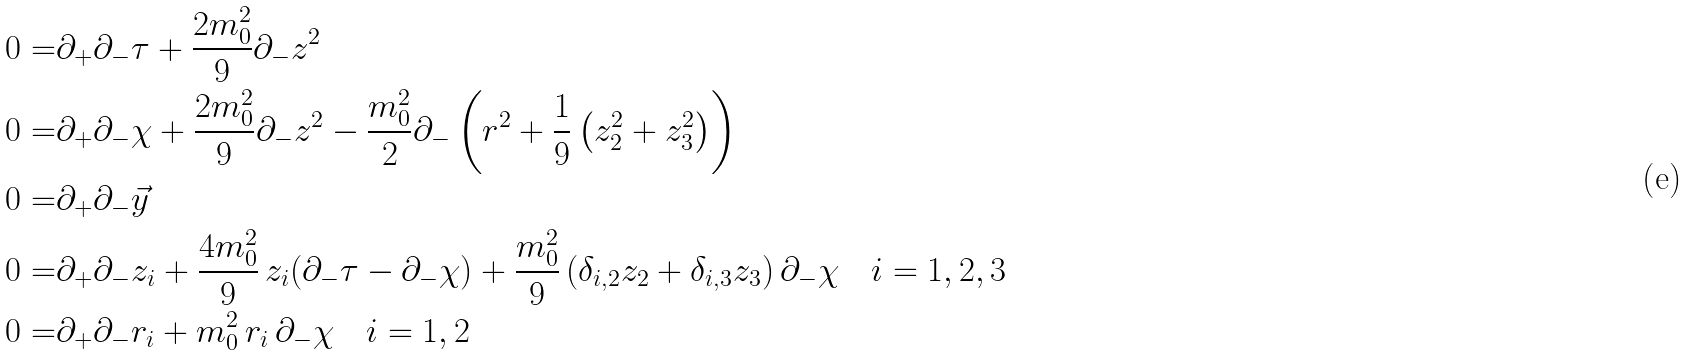<formula> <loc_0><loc_0><loc_500><loc_500>0 = & \partial _ { + } \partial _ { - } \tau + \frac { 2 m _ { 0 } ^ { 2 } } { 9 } \partial _ { - } z ^ { 2 } \\ 0 = & \partial _ { + } \partial _ { - } \chi + \frac { 2 m _ { 0 } ^ { 2 } } { 9 } \partial _ { - } z ^ { 2 } - \frac { m _ { 0 } ^ { 2 } } { 2 } \partial _ { - } \left ( r ^ { 2 } + \frac { 1 } { 9 } \left ( z _ { 2 } ^ { 2 } + z _ { 3 } ^ { 2 } \right ) \right ) \\ 0 = & \partial _ { + } \partial _ { - } \vec { y } \\ 0 = & \partial _ { + } \partial _ { - } z _ { i } + \frac { 4 m _ { 0 } ^ { 2 } } { 9 } \, z _ { i } ( \partial _ { - } \tau - \partial _ { - } \chi ) + \frac { m _ { 0 } ^ { 2 } } { 9 } \left ( \delta _ { i , 2 } z _ { 2 } + \delta _ { i , 3 } z _ { 3 } \right ) \partial _ { - } \chi \quad i = 1 , 2 , 3 \\ 0 = & \partial _ { + } \partial _ { - } r _ { i } + m _ { 0 } ^ { 2 } \, r _ { i } \, \partial _ { - } \chi \quad i = 1 , 2</formula> 